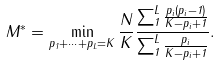Convert formula to latex. <formula><loc_0><loc_0><loc_500><loc_500>M ^ { * } = \min _ { p _ { 1 } + \dots + p _ { L } = K } \frac { N } { K } \frac { \sum _ { 1 } ^ { L } { \frac { p _ { i } ( p _ { i } - 1 ) } { K - p _ { i } + 1 } } } { \sum _ { 1 } ^ { L } { \frac { p _ { i } } { K - p _ { i } + 1 } } } .</formula> 